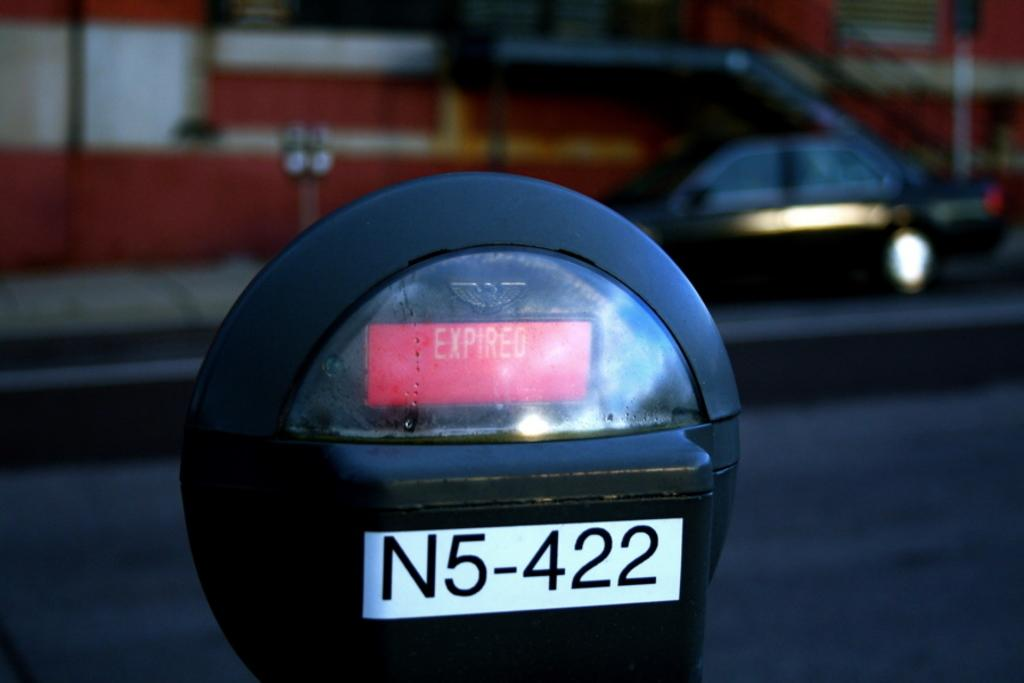<image>
Render a clear and concise summary of the photo. Parking meter that is expired and has the numbers N5422. 